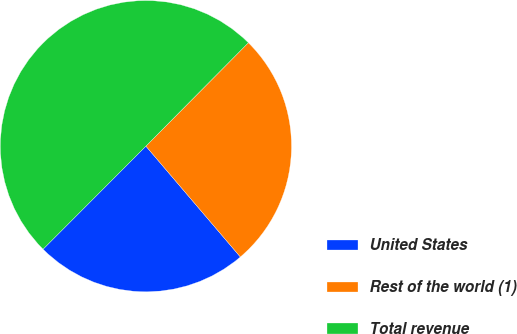Convert chart. <chart><loc_0><loc_0><loc_500><loc_500><pie_chart><fcel>United States<fcel>Rest of the world (1)<fcel>Total revenue<nl><fcel>23.72%<fcel>26.34%<fcel>49.94%<nl></chart> 